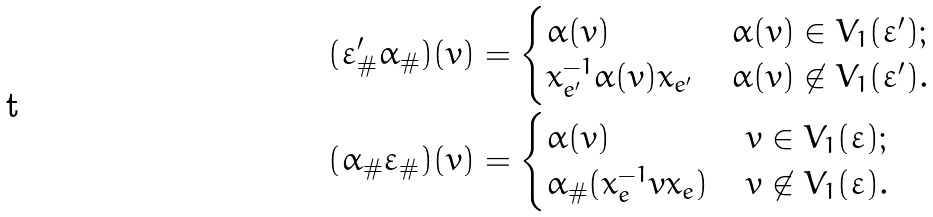Convert formula to latex. <formula><loc_0><loc_0><loc_500><loc_500>( \varepsilon ^ { \prime } _ { \# } \alpha _ { \# } ) ( v ) & = \begin{cases} \alpha ( v ) & \alpha ( v ) \in V _ { 1 } ( \varepsilon ^ { \prime } ) ; \\ x _ { e ^ { \prime } } ^ { - 1 } \alpha ( v ) x _ { e ^ { \prime } } & \alpha ( v ) \not \in V _ { 1 } ( \varepsilon ^ { \prime } ) . \end{cases} \\ ( \alpha _ { \# } \varepsilon _ { \# } ) ( v ) & = \begin{cases} \alpha ( v ) & v \in V _ { 1 } ( \varepsilon ) ; \\ \alpha _ { \# } ( x _ { e } ^ { - 1 } v x _ { e } ) & v \not \in V _ { 1 } ( \varepsilon ) . \end{cases}</formula> 